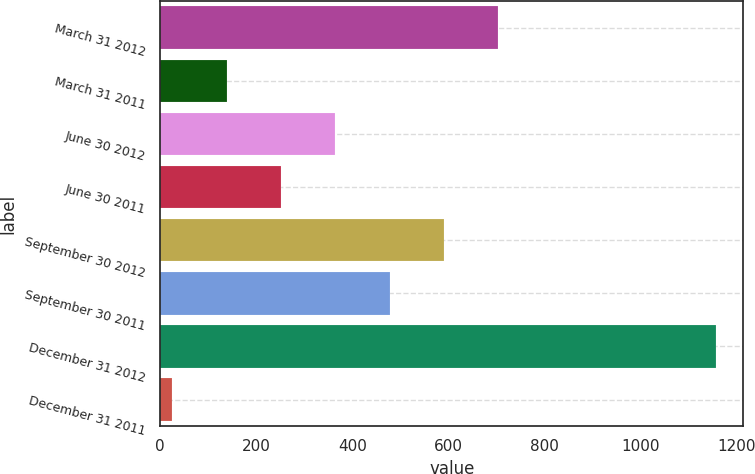Convert chart. <chart><loc_0><loc_0><loc_500><loc_500><bar_chart><fcel>March 31 2012<fcel>March 31 2011<fcel>June 30 2012<fcel>June 30 2011<fcel>September 30 2012<fcel>September 30 2011<fcel>December 31 2012<fcel>December 31 2011<nl><fcel>703.6<fcel>138.1<fcel>364.3<fcel>251.2<fcel>590.5<fcel>477.4<fcel>1156<fcel>25<nl></chart> 